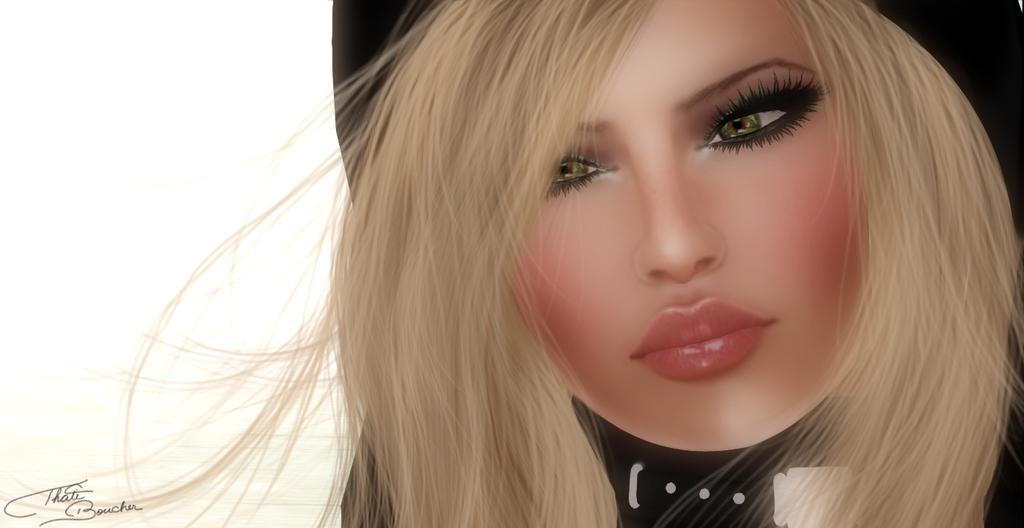What is the main subject of the image? The image contains an animation. Can you describe the main character in the animation? The animation features a woman. What is the woman wearing in the animation? The woman is wearing a black color dress. What type of stem can be seen growing from the woman's head in the animation? There is no stem growing from the woman's head in the animation. How many children does the woman have in the animation? The provided facts do not mention any children or family relationships for the woman in the animation. 